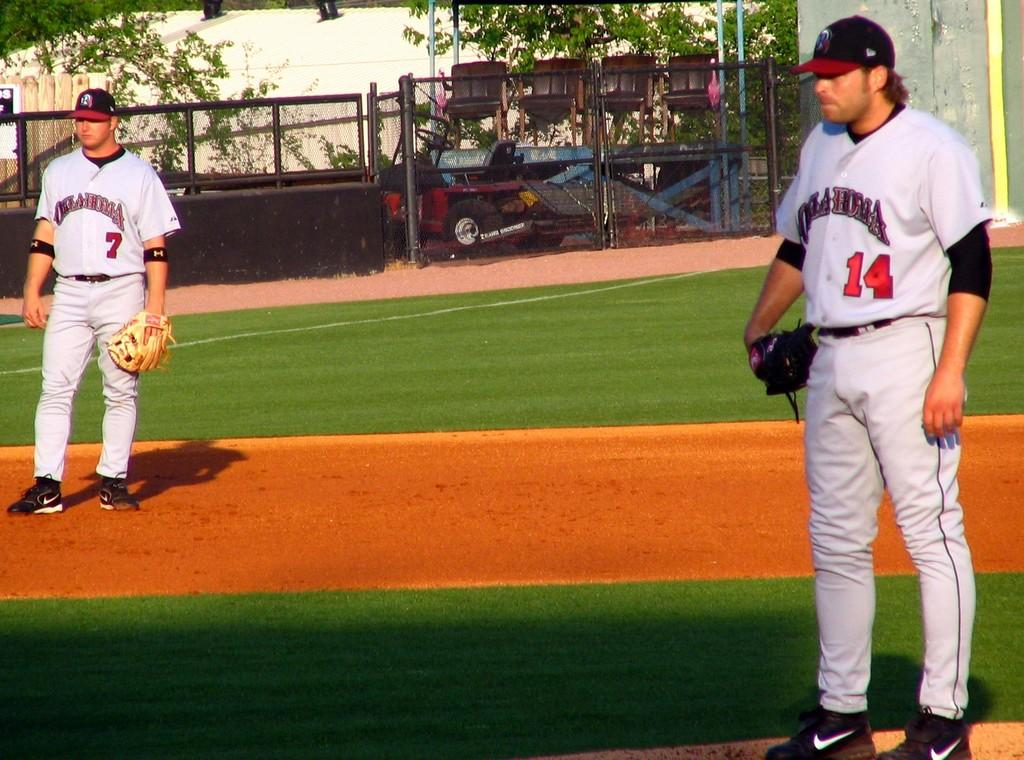Provide a one-sentence caption for the provided image. Oklahoma's pitcher is standing on the mound, with the third baseman to his right. 